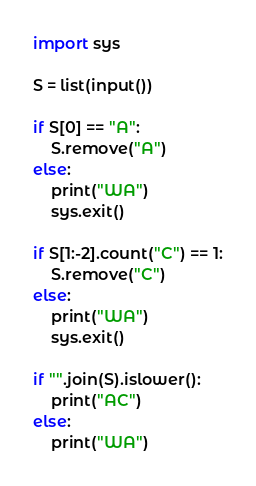Convert code to text. <code><loc_0><loc_0><loc_500><loc_500><_Python_>import sys

S = list(input())

if S[0] == "A":
    S.remove("A")
else:
    print("WA")
    sys.exit()

if S[1:-2].count("C") == 1:
    S.remove("C")
else:
    print("WA")
    sys.exit()

if "".join(S).islower():
    print("AC")
else:
    print("WA")</code> 